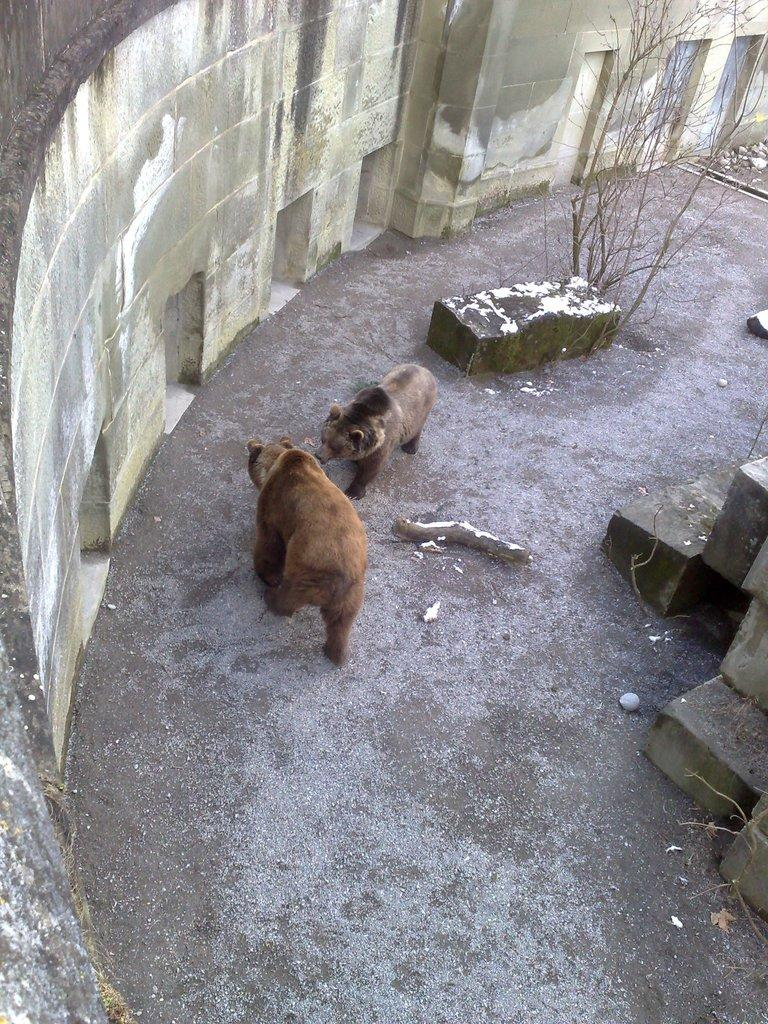How many bears are present in the image? There are two bears in the image. What color are the bears? The bears are brown in color. What can be seen in the background of the image? There are dried trees in the background of the image. What colors are present on the wall in the background? The wall in the background has gray, white, and cream colors. What type of sign can be seen hanging from the neck of one of the bears? There is no sign present in the image; the bears are not wearing any accessories. Can you see any sheep in the image? There are no sheep present in the image; the main subjects are the two brown bears. 